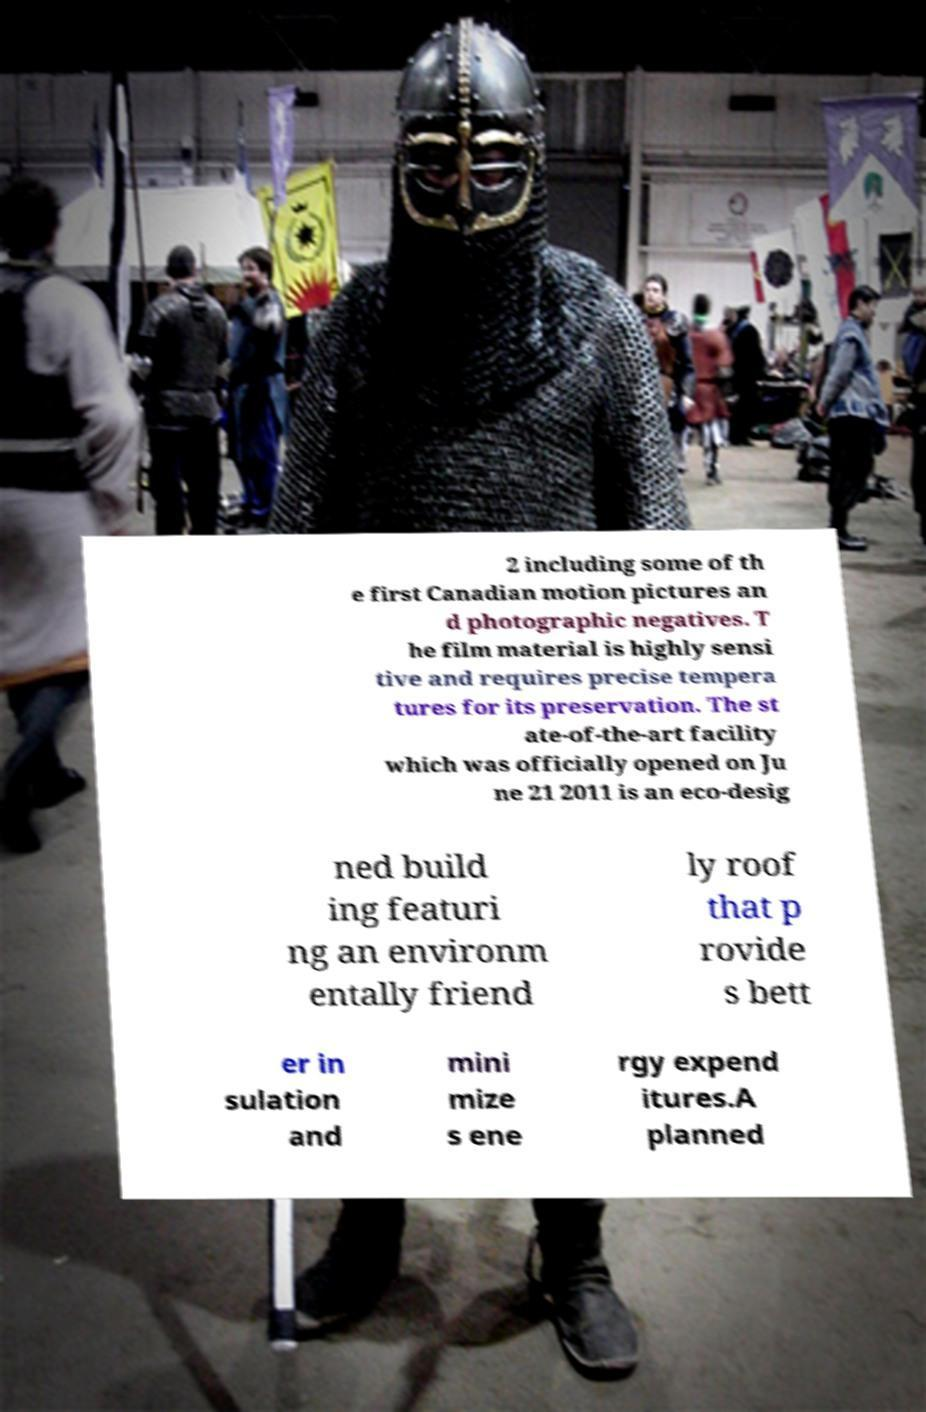Please identify and transcribe the text found in this image. 2 including some of th e first Canadian motion pictures an d photographic negatives. T he film material is highly sensi tive and requires precise tempera tures for its preservation. The st ate-of-the-art facility which was officially opened on Ju ne 21 2011 is an eco-desig ned build ing featuri ng an environm entally friend ly roof that p rovide s bett er in sulation and mini mize s ene rgy expend itures.A planned 